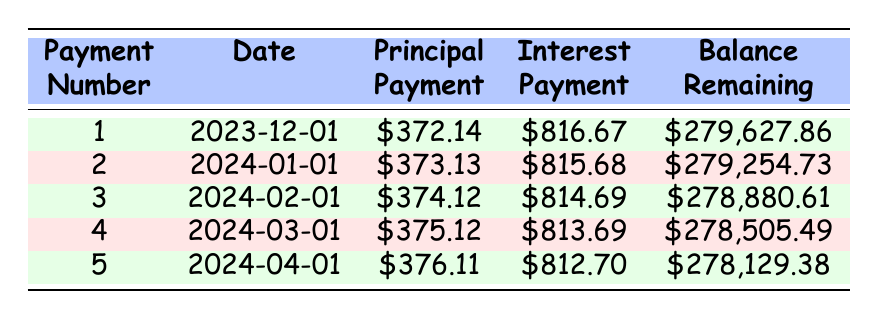What is the total principal payment made in the first 5 payments? To find the total principal payment made in the first 5 payments, we add all the principal payments together: 372.14 + 373.13 + 374.12 + 375.12 + 376.11 = 1870.62
Answer: 1870.62 What is the interest payment for the second payment? The interest payment for the second payment can be found under the "Interest Payment" column for payment number 2, which shows 815.68
Answer: 815.68 Is the remaining balance after the first payment greater than 279,000? The remaining balance after the first payment is 279,627.86. Since 279,627.86 is greater than 279,000, the answer is yes
Answer: Yes What is the monthly payment Scott is required to make? The table shows a monthly payment of 1264.14, which is a fixed amount Scott is required to pay each month
Answer: 1264.14 Which month and year is the third payment due? The third payment is due on 2024-02-01, as indicated in the date column for payment number 3
Answer: February 2024 What is the average interest payment for the first five payments? To calculate the average interest payment, we first sum the interest payments: 816.67 + 815.68 + 814.69 + 813.69 + 812.70 = 4083.43. Then, we divide by the number of payments (5): 4083.43 / 5 = 816.69
Answer: 816.69 Is the principal payment for the fifth payment higher than the fourth payment? The principal payment for the fifth payment is 376.11 and for the fourth payment, it's 375.12. Since 376.11 is greater than 375.12, the answer is yes
Answer: Yes What is the change in remaining balance from the first to the second payment? The remaining balance after the first payment is 279,627.86 and after the second payment is 279,254.73. The change is 279,627.86 - 279,254.73 = 373.13
Answer: 373.13 What is the total interest paid in the first five payments? To find the total interest paid, we sum the interest payments: 816.67 + 815.68 + 814.69 + 813.69 + 812.70 = 4083.43
Answer: 4083.43 